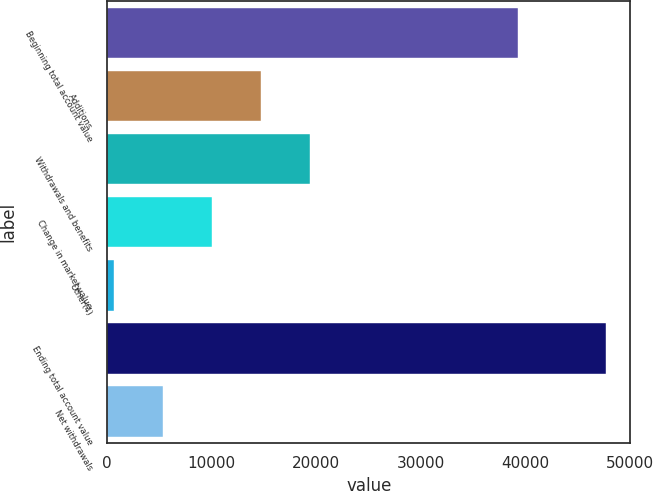Convert chart to OTSL. <chart><loc_0><loc_0><loc_500><loc_500><bar_chart><fcel>Beginning total account value<fcel>Additions<fcel>Withdrawals and benefits<fcel>Change in market value<fcel>Other(4)<fcel>Ending total account value<fcel>Net withdrawals<nl><fcel>39296<fcel>14752<fcel>19456<fcel>10048<fcel>640<fcel>47680<fcel>5344<nl></chart> 